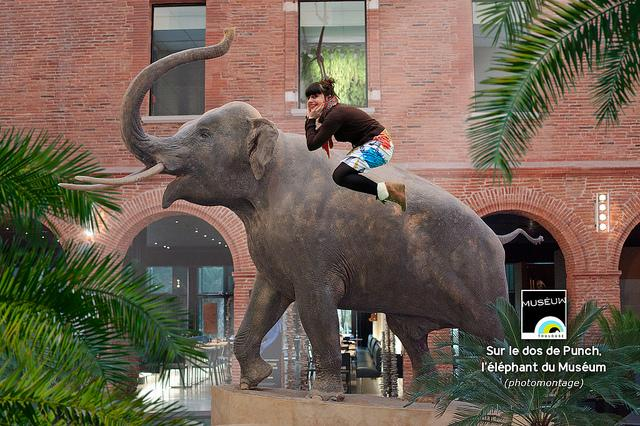What happened to this image? Please explain your reasoning. photoshopped. Someone put two different pictures together 